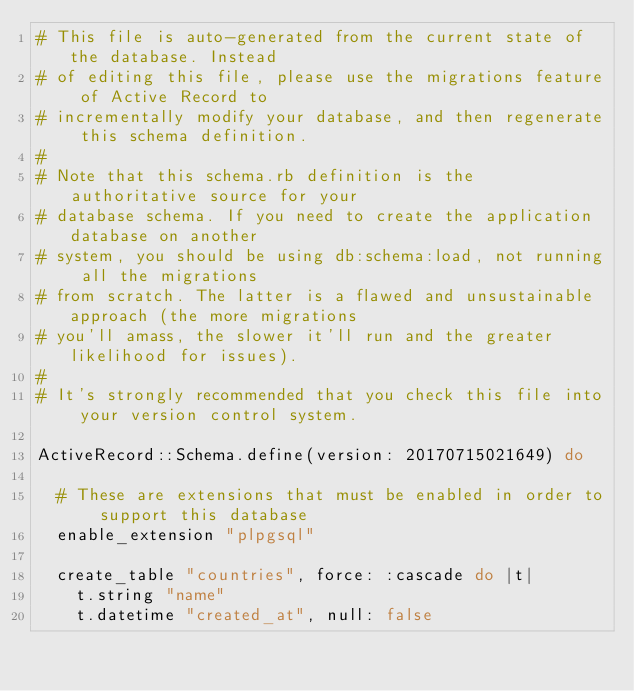<code> <loc_0><loc_0><loc_500><loc_500><_Ruby_># This file is auto-generated from the current state of the database. Instead
# of editing this file, please use the migrations feature of Active Record to
# incrementally modify your database, and then regenerate this schema definition.
#
# Note that this schema.rb definition is the authoritative source for your
# database schema. If you need to create the application database on another
# system, you should be using db:schema:load, not running all the migrations
# from scratch. The latter is a flawed and unsustainable approach (the more migrations
# you'll amass, the slower it'll run and the greater likelihood for issues).
#
# It's strongly recommended that you check this file into your version control system.

ActiveRecord::Schema.define(version: 20170715021649) do

  # These are extensions that must be enabled in order to support this database
  enable_extension "plpgsql"

  create_table "countries", force: :cascade do |t|
    t.string "name"
    t.datetime "created_at", null: false</code> 